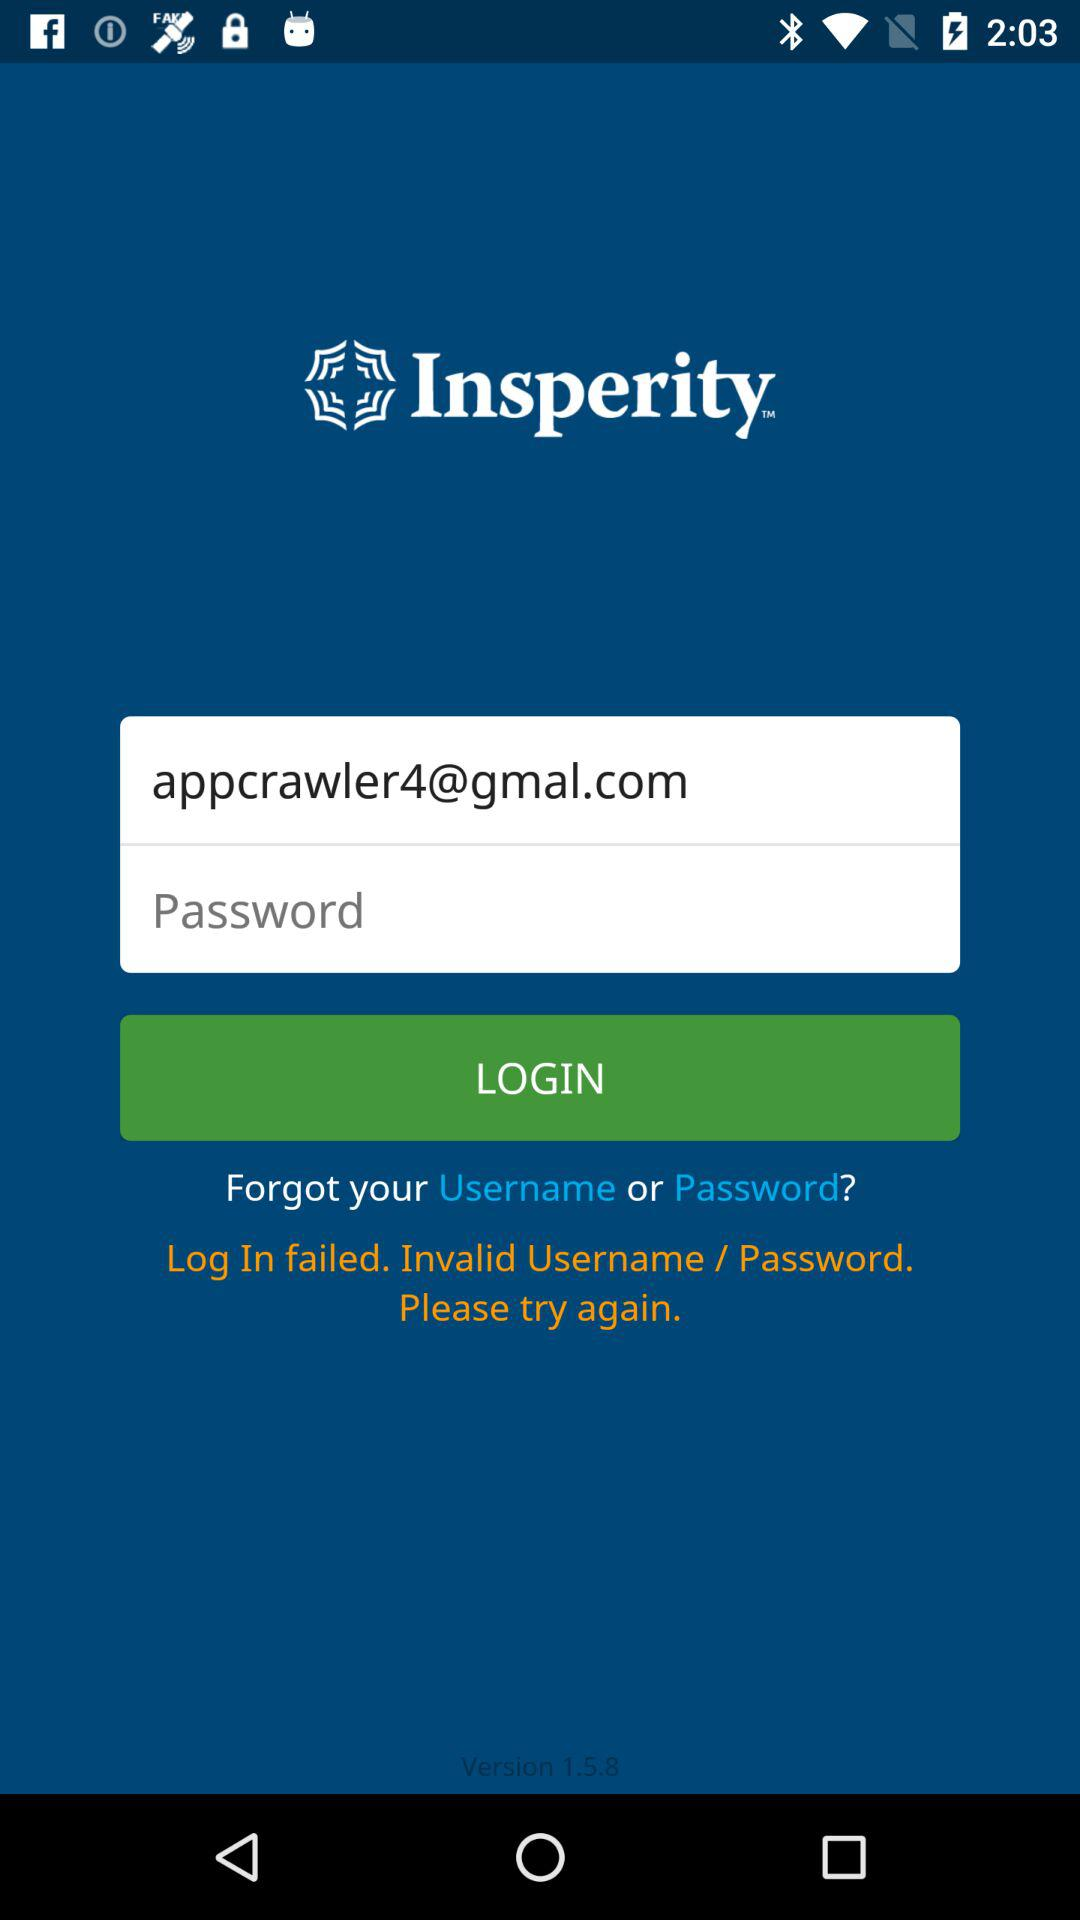What is the name of the application? The name of the application is "Insperity". 